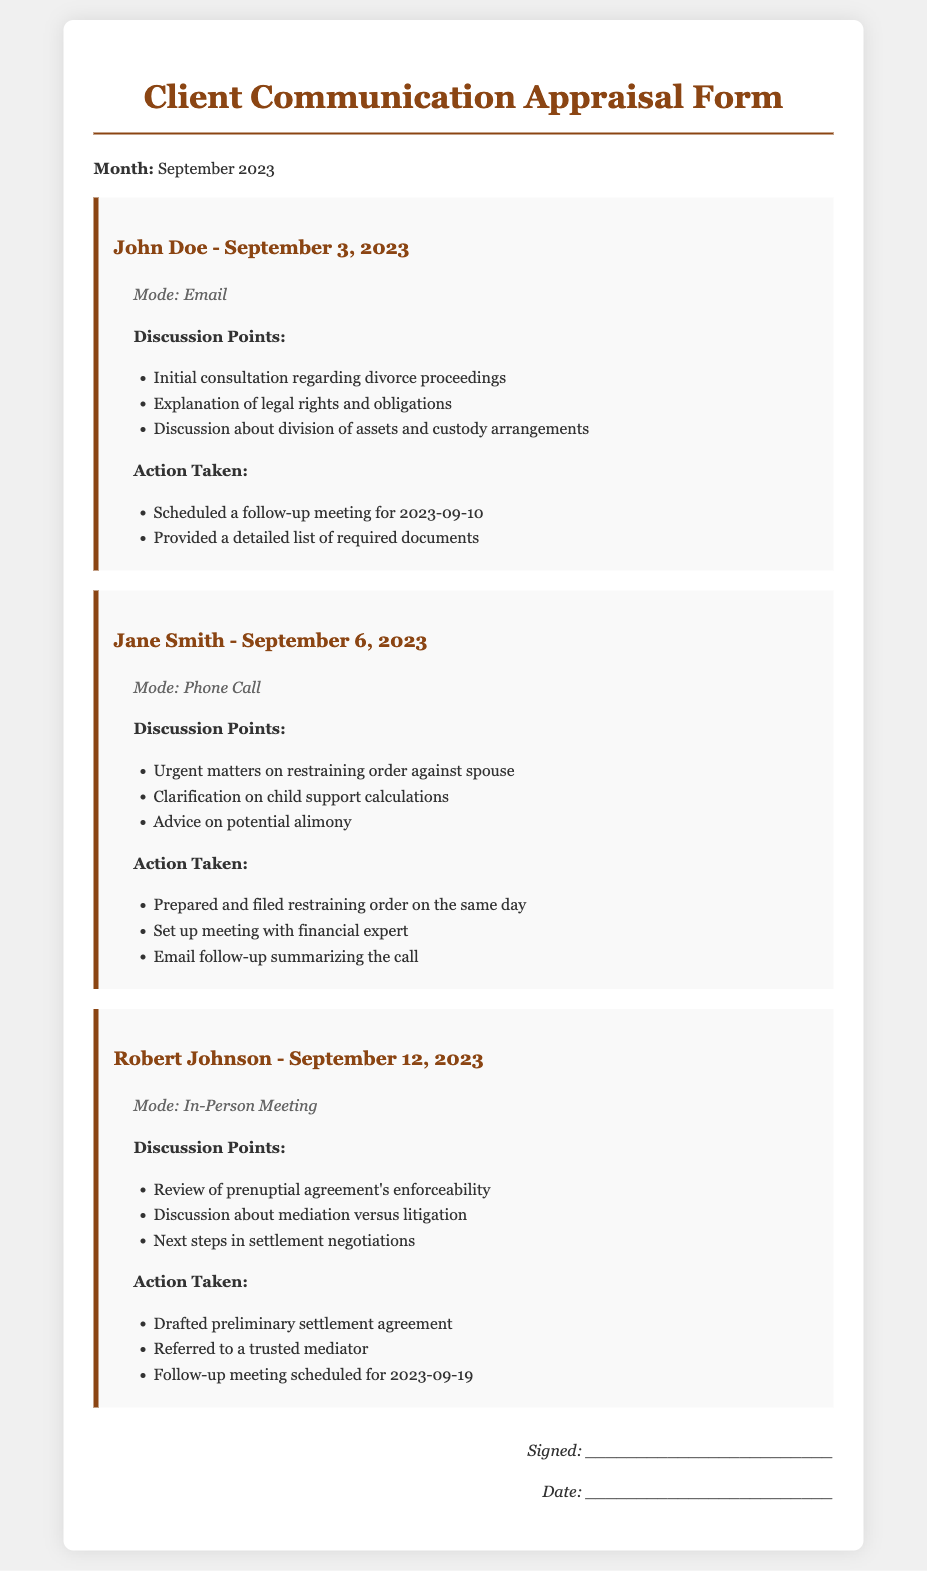What is the month of the document? The document explicitly states the month at the top, which is September 2023.
Answer: September 2023 Who is the client on September 6, 2023? The name of the client listed for that date is provided in the interaction section.
Answer: Jane Smith What mode of communication was used for John Doe? The mode of communication for John Doe is clearly indicated in the interaction details.
Answer: Email How many action items were taken for Jane Smith? The document lists three action items taken during the interaction with Jane Smith.
Answer: Three What was the date of the follow-up meeting for Robert Johnson? The follow-up meeting date for Robert Johnson is noted in the action items section of his interaction.
Answer: September 19, 2023 What was one of the discussion points for Jane Smith? A specific discussion point for Jane Smith is mentioned within her interaction details and can be found easily.
Answer: Urgent matters on restraining order against spouse What is one action taken for John Doe? The actions listed for John Doe provide information on what follow-up was planned.
Answer: Scheduled a follow-up meeting for 2023-09-10 What is the primary purpose of this document? The document's title indicates its nature and purpose, focusing on client interactions and communications.
Answer: Client Communication Appraisal Form 